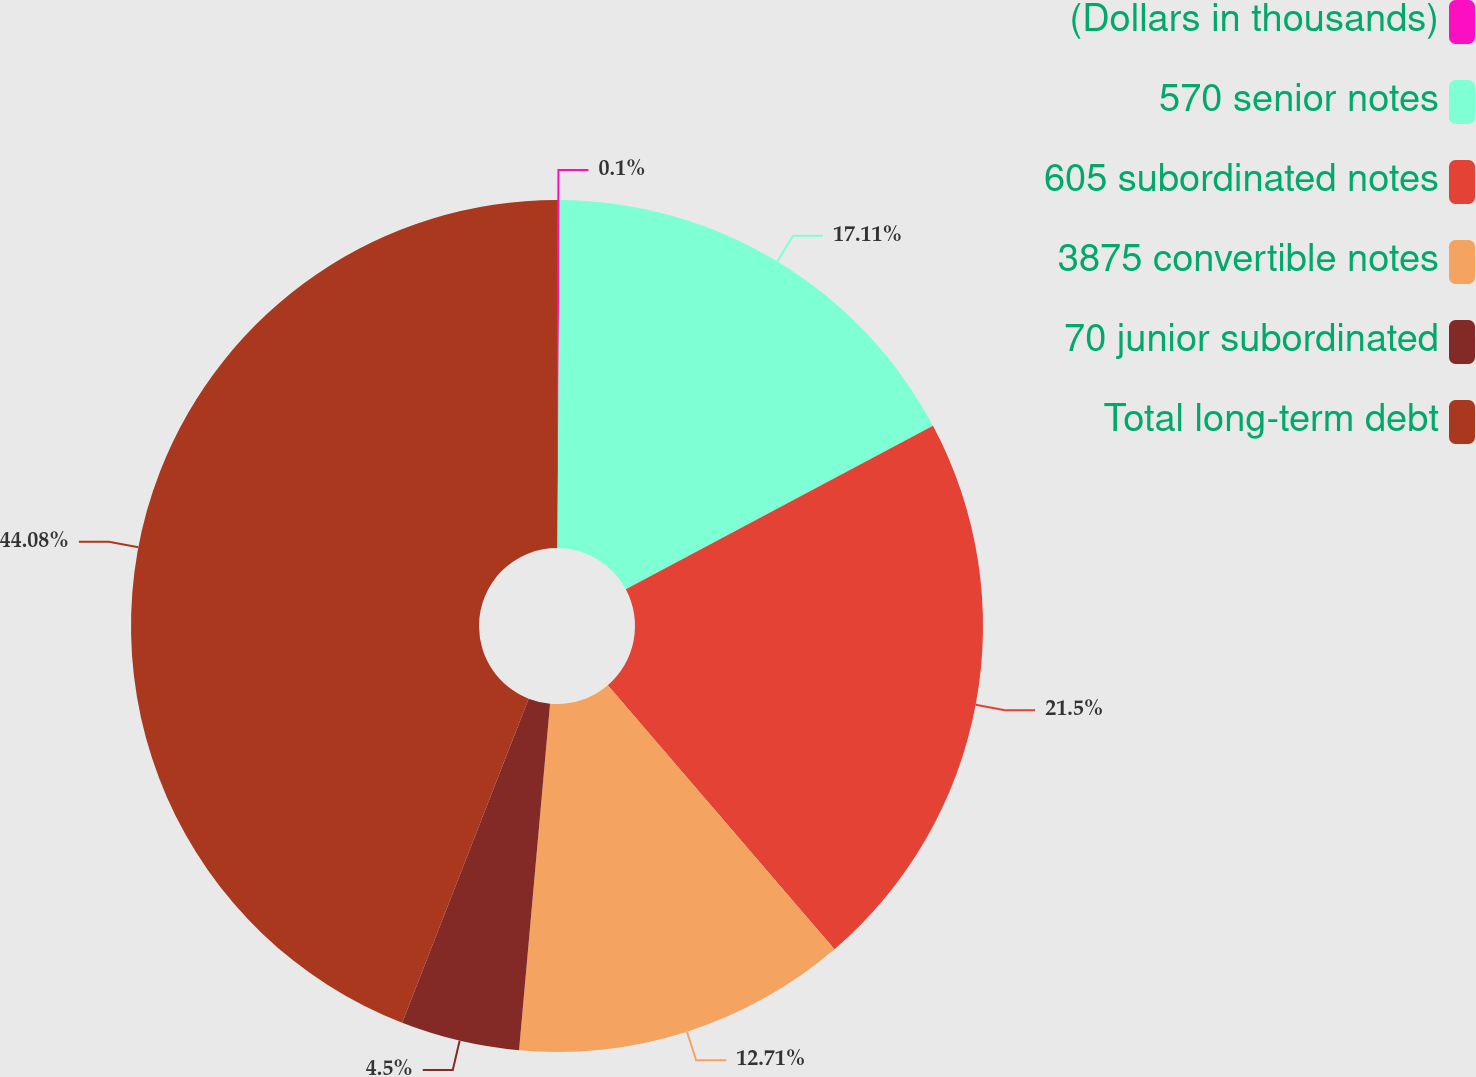Convert chart to OTSL. <chart><loc_0><loc_0><loc_500><loc_500><pie_chart><fcel>(Dollars in thousands)<fcel>570 senior notes<fcel>605 subordinated notes<fcel>3875 convertible notes<fcel>70 junior subordinated<fcel>Total long-term debt<nl><fcel>0.1%<fcel>17.11%<fcel>21.5%<fcel>12.71%<fcel>4.5%<fcel>44.08%<nl></chart> 